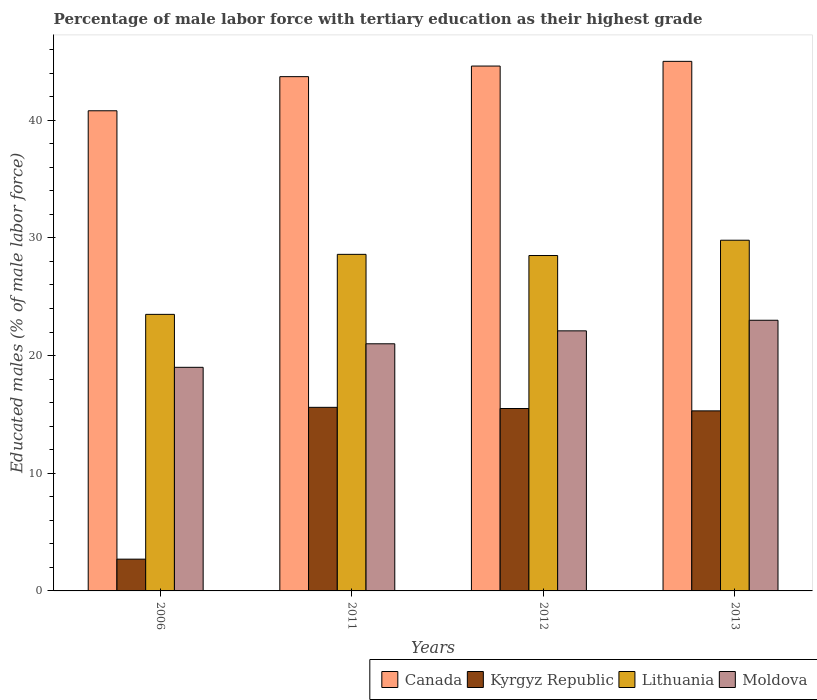How many different coloured bars are there?
Ensure brevity in your answer.  4. How many groups of bars are there?
Your answer should be compact. 4. Are the number of bars per tick equal to the number of legend labels?
Your response must be concise. Yes. Are the number of bars on each tick of the X-axis equal?
Provide a succinct answer. Yes. How many bars are there on the 4th tick from the right?
Your answer should be compact. 4. What is the label of the 4th group of bars from the left?
Keep it short and to the point. 2013. What is the percentage of male labor force with tertiary education in Kyrgyz Republic in 2006?
Offer a terse response. 2.7. Across all years, what is the maximum percentage of male labor force with tertiary education in Lithuania?
Your response must be concise. 29.8. Across all years, what is the minimum percentage of male labor force with tertiary education in Canada?
Give a very brief answer. 40.8. What is the total percentage of male labor force with tertiary education in Lithuania in the graph?
Give a very brief answer. 110.4. What is the difference between the percentage of male labor force with tertiary education in Lithuania in 2006 and that in 2012?
Keep it short and to the point. -5. What is the difference between the percentage of male labor force with tertiary education in Lithuania in 2011 and the percentage of male labor force with tertiary education in Canada in 2012?
Give a very brief answer. -16. What is the average percentage of male labor force with tertiary education in Lithuania per year?
Your response must be concise. 27.6. In the year 2011, what is the difference between the percentage of male labor force with tertiary education in Kyrgyz Republic and percentage of male labor force with tertiary education in Moldova?
Make the answer very short. -5.4. What is the ratio of the percentage of male labor force with tertiary education in Moldova in 2012 to that in 2013?
Provide a short and direct response. 0.96. Is the percentage of male labor force with tertiary education in Kyrgyz Republic in 2011 less than that in 2012?
Your answer should be compact. No. Is the difference between the percentage of male labor force with tertiary education in Kyrgyz Republic in 2012 and 2013 greater than the difference between the percentage of male labor force with tertiary education in Moldova in 2012 and 2013?
Offer a very short reply. Yes. What is the difference between the highest and the second highest percentage of male labor force with tertiary education in Canada?
Offer a very short reply. 0.4. What is the difference between the highest and the lowest percentage of male labor force with tertiary education in Kyrgyz Republic?
Offer a terse response. 12.9. In how many years, is the percentage of male labor force with tertiary education in Moldova greater than the average percentage of male labor force with tertiary education in Moldova taken over all years?
Give a very brief answer. 2. Is the sum of the percentage of male labor force with tertiary education in Lithuania in 2006 and 2012 greater than the maximum percentage of male labor force with tertiary education in Moldova across all years?
Ensure brevity in your answer.  Yes. What does the 2nd bar from the left in 2012 represents?
Offer a very short reply. Kyrgyz Republic. What does the 3rd bar from the right in 2012 represents?
Your answer should be very brief. Kyrgyz Republic. Is it the case that in every year, the sum of the percentage of male labor force with tertiary education in Kyrgyz Republic and percentage of male labor force with tertiary education in Canada is greater than the percentage of male labor force with tertiary education in Moldova?
Your answer should be very brief. Yes. How many bars are there?
Offer a very short reply. 16. How many years are there in the graph?
Give a very brief answer. 4. Are the values on the major ticks of Y-axis written in scientific E-notation?
Your response must be concise. No. Does the graph contain any zero values?
Your answer should be very brief. No. How many legend labels are there?
Make the answer very short. 4. How are the legend labels stacked?
Offer a terse response. Horizontal. What is the title of the graph?
Your answer should be very brief. Percentage of male labor force with tertiary education as their highest grade. What is the label or title of the Y-axis?
Make the answer very short. Educated males (% of male labor force). What is the Educated males (% of male labor force) in Canada in 2006?
Your answer should be very brief. 40.8. What is the Educated males (% of male labor force) of Kyrgyz Republic in 2006?
Provide a short and direct response. 2.7. What is the Educated males (% of male labor force) in Canada in 2011?
Provide a short and direct response. 43.7. What is the Educated males (% of male labor force) in Kyrgyz Republic in 2011?
Provide a short and direct response. 15.6. What is the Educated males (% of male labor force) in Lithuania in 2011?
Give a very brief answer. 28.6. What is the Educated males (% of male labor force) in Moldova in 2011?
Offer a very short reply. 21. What is the Educated males (% of male labor force) of Canada in 2012?
Your response must be concise. 44.6. What is the Educated males (% of male labor force) in Lithuania in 2012?
Your answer should be compact. 28.5. What is the Educated males (% of male labor force) of Moldova in 2012?
Your answer should be compact. 22.1. What is the Educated males (% of male labor force) in Kyrgyz Republic in 2013?
Provide a succinct answer. 15.3. What is the Educated males (% of male labor force) in Lithuania in 2013?
Provide a short and direct response. 29.8. What is the Educated males (% of male labor force) in Moldova in 2013?
Ensure brevity in your answer.  23. Across all years, what is the maximum Educated males (% of male labor force) of Kyrgyz Republic?
Your answer should be compact. 15.6. Across all years, what is the maximum Educated males (% of male labor force) in Lithuania?
Your answer should be compact. 29.8. Across all years, what is the minimum Educated males (% of male labor force) of Canada?
Your response must be concise. 40.8. Across all years, what is the minimum Educated males (% of male labor force) in Kyrgyz Republic?
Ensure brevity in your answer.  2.7. Across all years, what is the minimum Educated males (% of male labor force) in Lithuania?
Offer a very short reply. 23.5. What is the total Educated males (% of male labor force) of Canada in the graph?
Offer a very short reply. 174.1. What is the total Educated males (% of male labor force) in Kyrgyz Republic in the graph?
Give a very brief answer. 49.1. What is the total Educated males (% of male labor force) of Lithuania in the graph?
Your answer should be very brief. 110.4. What is the total Educated males (% of male labor force) of Moldova in the graph?
Ensure brevity in your answer.  85.1. What is the difference between the Educated males (% of male labor force) in Kyrgyz Republic in 2006 and that in 2011?
Make the answer very short. -12.9. What is the difference between the Educated males (% of male labor force) in Lithuania in 2006 and that in 2011?
Provide a short and direct response. -5.1. What is the difference between the Educated males (% of male labor force) in Moldova in 2006 and that in 2012?
Your response must be concise. -3.1. What is the difference between the Educated males (% of male labor force) of Canada in 2006 and that in 2013?
Give a very brief answer. -4.2. What is the difference between the Educated males (% of male labor force) of Kyrgyz Republic in 2006 and that in 2013?
Your answer should be very brief. -12.6. What is the difference between the Educated males (% of male labor force) of Moldova in 2006 and that in 2013?
Give a very brief answer. -4. What is the difference between the Educated males (% of male labor force) of Canada in 2011 and that in 2012?
Your answer should be very brief. -0.9. What is the difference between the Educated males (% of male labor force) of Lithuania in 2011 and that in 2012?
Your response must be concise. 0.1. What is the difference between the Educated males (% of male labor force) of Lithuania in 2011 and that in 2013?
Your answer should be compact. -1.2. What is the difference between the Educated males (% of male labor force) in Kyrgyz Republic in 2012 and that in 2013?
Provide a succinct answer. 0.2. What is the difference between the Educated males (% of male labor force) of Lithuania in 2012 and that in 2013?
Offer a terse response. -1.3. What is the difference between the Educated males (% of male labor force) of Moldova in 2012 and that in 2013?
Ensure brevity in your answer.  -0.9. What is the difference between the Educated males (% of male labor force) in Canada in 2006 and the Educated males (% of male labor force) in Kyrgyz Republic in 2011?
Your answer should be compact. 25.2. What is the difference between the Educated males (% of male labor force) in Canada in 2006 and the Educated males (% of male labor force) in Moldova in 2011?
Make the answer very short. 19.8. What is the difference between the Educated males (% of male labor force) in Kyrgyz Republic in 2006 and the Educated males (% of male labor force) in Lithuania in 2011?
Give a very brief answer. -25.9. What is the difference between the Educated males (% of male labor force) of Kyrgyz Republic in 2006 and the Educated males (% of male labor force) of Moldova in 2011?
Offer a terse response. -18.3. What is the difference between the Educated males (% of male labor force) in Canada in 2006 and the Educated males (% of male labor force) in Kyrgyz Republic in 2012?
Your response must be concise. 25.3. What is the difference between the Educated males (% of male labor force) in Canada in 2006 and the Educated males (% of male labor force) in Lithuania in 2012?
Give a very brief answer. 12.3. What is the difference between the Educated males (% of male labor force) in Kyrgyz Republic in 2006 and the Educated males (% of male labor force) in Lithuania in 2012?
Make the answer very short. -25.8. What is the difference between the Educated males (% of male labor force) in Kyrgyz Republic in 2006 and the Educated males (% of male labor force) in Moldova in 2012?
Ensure brevity in your answer.  -19.4. What is the difference between the Educated males (% of male labor force) of Kyrgyz Republic in 2006 and the Educated males (% of male labor force) of Lithuania in 2013?
Your answer should be compact. -27.1. What is the difference between the Educated males (% of male labor force) in Kyrgyz Republic in 2006 and the Educated males (% of male labor force) in Moldova in 2013?
Ensure brevity in your answer.  -20.3. What is the difference between the Educated males (% of male labor force) in Lithuania in 2006 and the Educated males (% of male labor force) in Moldova in 2013?
Offer a terse response. 0.5. What is the difference between the Educated males (% of male labor force) in Canada in 2011 and the Educated males (% of male labor force) in Kyrgyz Republic in 2012?
Make the answer very short. 28.2. What is the difference between the Educated males (% of male labor force) in Canada in 2011 and the Educated males (% of male labor force) in Lithuania in 2012?
Offer a terse response. 15.2. What is the difference between the Educated males (% of male labor force) of Canada in 2011 and the Educated males (% of male labor force) of Moldova in 2012?
Provide a succinct answer. 21.6. What is the difference between the Educated males (% of male labor force) in Canada in 2011 and the Educated males (% of male labor force) in Kyrgyz Republic in 2013?
Provide a short and direct response. 28.4. What is the difference between the Educated males (% of male labor force) in Canada in 2011 and the Educated males (% of male labor force) in Moldova in 2013?
Your response must be concise. 20.7. What is the difference between the Educated males (% of male labor force) of Canada in 2012 and the Educated males (% of male labor force) of Kyrgyz Republic in 2013?
Give a very brief answer. 29.3. What is the difference between the Educated males (% of male labor force) in Canada in 2012 and the Educated males (% of male labor force) in Lithuania in 2013?
Your answer should be very brief. 14.8. What is the difference between the Educated males (% of male labor force) in Canada in 2012 and the Educated males (% of male labor force) in Moldova in 2013?
Offer a terse response. 21.6. What is the difference between the Educated males (% of male labor force) of Kyrgyz Republic in 2012 and the Educated males (% of male labor force) of Lithuania in 2013?
Your answer should be compact. -14.3. What is the difference between the Educated males (% of male labor force) of Kyrgyz Republic in 2012 and the Educated males (% of male labor force) of Moldova in 2013?
Keep it short and to the point. -7.5. What is the difference between the Educated males (% of male labor force) of Lithuania in 2012 and the Educated males (% of male labor force) of Moldova in 2013?
Your answer should be very brief. 5.5. What is the average Educated males (% of male labor force) of Canada per year?
Give a very brief answer. 43.52. What is the average Educated males (% of male labor force) in Kyrgyz Republic per year?
Make the answer very short. 12.28. What is the average Educated males (% of male labor force) in Lithuania per year?
Your answer should be very brief. 27.6. What is the average Educated males (% of male labor force) in Moldova per year?
Provide a short and direct response. 21.27. In the year 2006, what is the difference between the Educated males (% of male labor force) of Canada and Educated males (% of male labor force) of Kyrgyz Republic?
Your answer should be compact. 38.1. In the year 2006, what is the difference between the Educated males (% of male labor force) of Canada and Educated males (% of male labor force) of Lithuania?
Your response must be concise. 17.3. In the year 2006, what is the difference between the Educated males (% of male labor force) of Canada and Educated males (% of male labor force) of Moldova?
Provide a succinct answer. 21.8. In the year 2006, what is the difference between the Educated males (% of male labor force) of Kyrgyz Republic and Educated males (% of male labor force) of Lithuania?
Provide a short and direct response. -20.8. In the year 2006, what is the difference between the Educated males (% of male labor force) in Kyrgyz Republic and Educated males (% of male labor force) in Moldova?
Offer a terse response. -16.3. In the year 2006, what is the difference between the Educated males (% of male labor force) of Lithuania and Educated males (% of male labor force) of Moldova?
Ensure brevity in your answer.  4.5. In the year 2011, what is the difference between the Educated males (% of male labor force) in Canada and Educated males (% of male labor force) in Kyrgyz Republic?
Ensure brevity in your answer.  28.1. In the year 2011, what is the difference between the Educated males (% of male labor force) in Canada and Educated males (% of male labor force) in Lithuania?
Your answer should be compact. 15.1. In the year 2011, what is the difference between the Educated males (% of male labor force) of Canada and Educated males (% of male labor force) of Moldova?
Make the answer very short. 22.7. In the year 2011, what is the difference between the Educated males (% of male labor force) of Kyrgyz Republic and Educated males (% of male labor force) of Moldova?
Make the answer very short. -5.4. In the year 2012, what is the difference between the Educated males (% of male labor force) of Canada and Educated males (% of male labor force) of Kyrgyz Republic?
Offer a very short reply. 29.1. In the year 2012, what is the difference between the Educated males (% of male labor force) in Canada and Educated males (% of male labor force) in Moldova?
Offer a terse response. 22.5. In the year 2013, what is the difference between the Educated males (% of male labor force) in Canada and Educated males (% of male labor force) in Kyrgyz Republic?
Give a very brief answer. 29.7. In the year 2013, what is the difference between the Educated males (% of male labor force) of Canada and Educated males (% of male labor force) of Lithuania?
Give a very brief answer. 15.2. In the year 2013, what is the difference between the Educated males (% of male labor force) of Kyrgyz Republic and Educated males (% of male labor force) of Lithuania?
Make the answer very short. -14.5. What is the ratio of the Educated males (% of male labor force) in Canada in 2006 to that in 2011?
Ensure brevity in your answer.  0.93. What is the ratio of the Educated males (% of male labor force) in Kyrgyz Republic in 2006 to that in 2011?
Keep it short and to the point. 0.17. What is the ratio of the Educated males (% of male labor force) in Lithuania in 2006 to that in 2011?
Give a very brief answer. 0.82. What is the ratio of the Educated males (% of male labor force) in Moldova in 2006 to that in 2011?
Your answer should be compact. 0.9. What is the ratio of the Educated males (% of male labor force) in Canada in 2006 to that in 2012?
Ensure brevity in your answer.  0.91. What is the ratio of the Educated males (% of male labor force) of Kyrgyz Republic in 2006 to that in 2012?
Provide a short and direct response. 0.17. What is the ratio of the Educated males (% of male labor force) in Lithuania in 2006 to that in 2012?
Your answer should be compact. 0.82. What is the ratio of the Educated males (% of male labor force) in Moldova in 2006 to that in 2012?
Give a very brief answer. 0.86. What is the ratio of the Educated males (% of male labor force) of Canada in 2006 to that in 2013?
Provide a succinct answer. 0.91. What is the ratio of the Educated males (% of male labor force) of Kyrgyz Republic in 2006 to that in 2013?
Make the answer very short. 0.18. What is the ratio of the Educated males (% of male labor force) of Lithuania in 2006 to that in 2013?
Ensure brevity in your answer.  0.79. What is the ratio of the Educated males (% of male labor force) of Moldova in 2006 to that in 2013?
Your answer should be compact. 0.83. What is the ratio of the Educated males (% of male labor force) of Canada in 2011 to that in 2012?
Your answer should be very brief. 0.98. What is the ratio of the Educated males (% of male labor force) of Moldova in 2011 to that in 2012?
Your response must be concise. 0.95. What is the ratio of the Educated males (% of male labor force) in Canada in 2011 to that in 2013?
Your response must be concise. 0.97. What is the ratio of the Educated males (% of male labor force) of Kyrgyz Republic in 2011 to that in 2013?
Provide a succinct answer. 1.02. What is the ratio of the Educated males (% of male labor force) in Lithuania in 2011 to that in 2013?
Offer a very short reply. 0.96. What is the ratio of the Educated males (% of male labor force) of Moldova in 2011 to that in 2013?
Provide a succinct answer. 0.91. What is the ratio of the Educated males (% of male labor force) in Canada in 2012 to that in 2013?
Give a very brief answer. 0.99. What is the ratio of the Educated males (% of male labor force) in Kyrgyz Republic in 2012 to that in 2013?
Offer a very short reply. 1.01. What is the ratio of the Educated males (% of male labor force) of Lithuania in 2012 to that in 2013?
Your response must be concise. 0.96. What is the ratio of the Educated males (% of male labor force) in Moldova in 2012 to that in 2013?
Your response must be concise. 0.96. What is the difference between the highest and the second highest Educated males (% of male labor force) of Moldova?
Ensure brevity in your answer.  0.9. What is the difference between the highest and the lowest Educated males (% of male labor force) in Canada?
Keep it short and to the point. 4.2. What is the difference between the highest and the lowest Educated males (% of male labor force) of Kyrgyz Republic?
Provide a short and direct response. 12.9. What is the difference between the highest and the lowest Educated males (% of male labor force) of Moldova?
Offer a terse response. 4. 